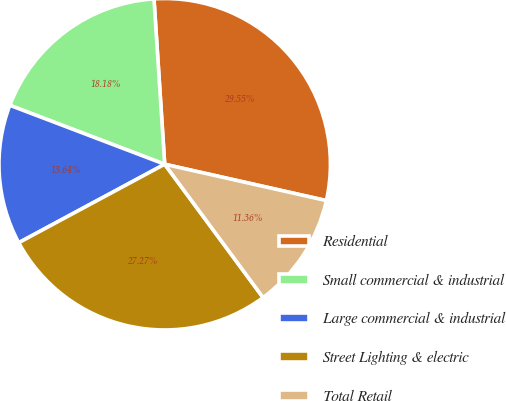Convert chart to OTSL. <chart><loc_0><loc_0><loc_500><loc_500><pie_chart><fcel>Residential<fcel>Small commercial & industrial<fcel>Large commercial & industrial<fcel>Street Lighting & electric<fcel>Total Retail<nl><fcel>29.55%<fcel>18.18%<fcel>13.64%<fcel>27.27%<fcel>11.36%<nl></chart> 